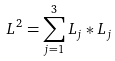Convert formula to latex. <formula><loc_0><loc_0><loc_500><loc_500>L ^ { 2 } = \sum _ { j = 1 } ^ { 3 } L _ { j } * L _ { j }</formula> 